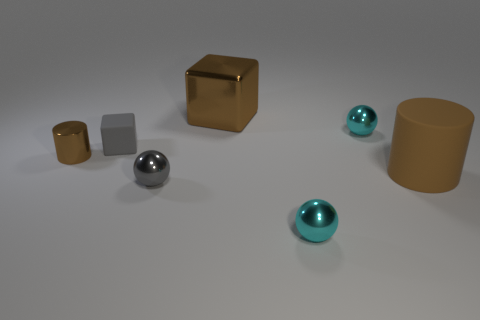Add 2 big brown shiny blocks. How many objects exist? 9 Subtract all cylinders. How many objects are left? 5 Subtract 0 cyan cylinders. How many objects are left? 7 Subtract all small brown metallic cylinders. Subtract all blue balls. How many objects are left? 6 Add 7 metallic spheres. How many metallic spheres are left? 10 Add 1 large matte things. How many large matte things exist? 2 